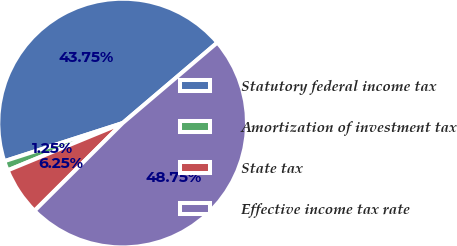Convert chart. <chart><loc_0><loc_0><loc_500><loc_500><pie_chart><fcel>Statutory federal income tax<fcel>Amortization of investment tax<fcel>State tax<fcel>Effective income tax rate<nl><fcel>43.75%<fcel>1.25%<fcel>6.25%<fcel>48.75%<nl></chart> 